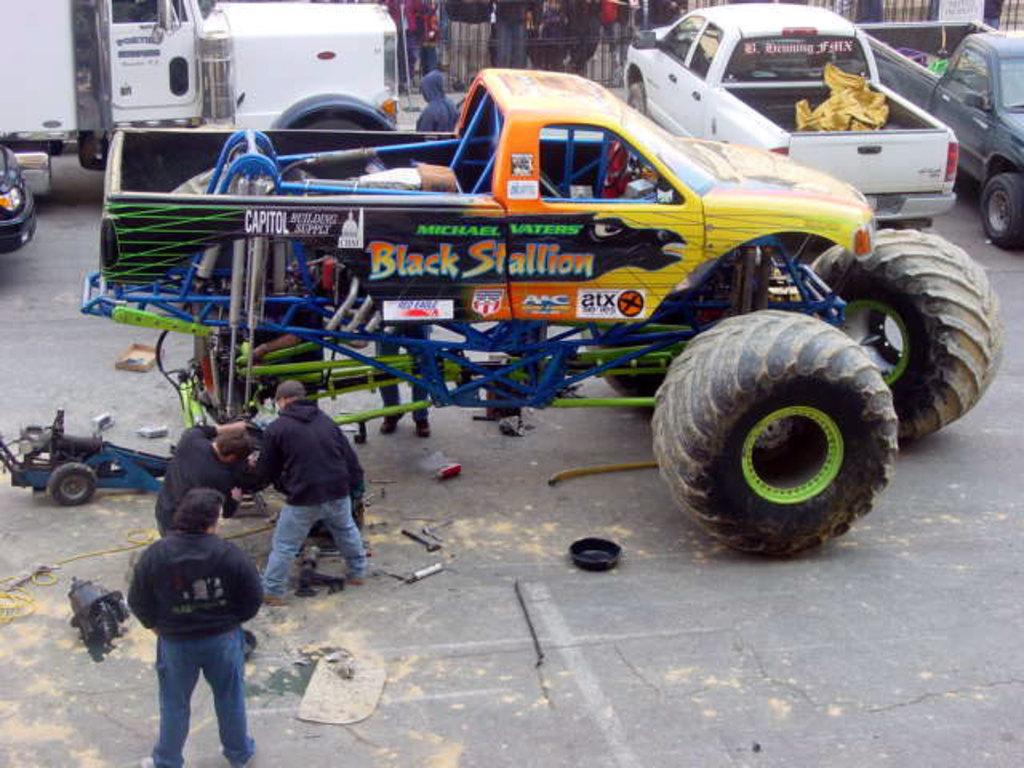<image>
Give a short and clear explanation of the subsequent image. A huge monster truck has Black Stallion on its side in multicolored style. 